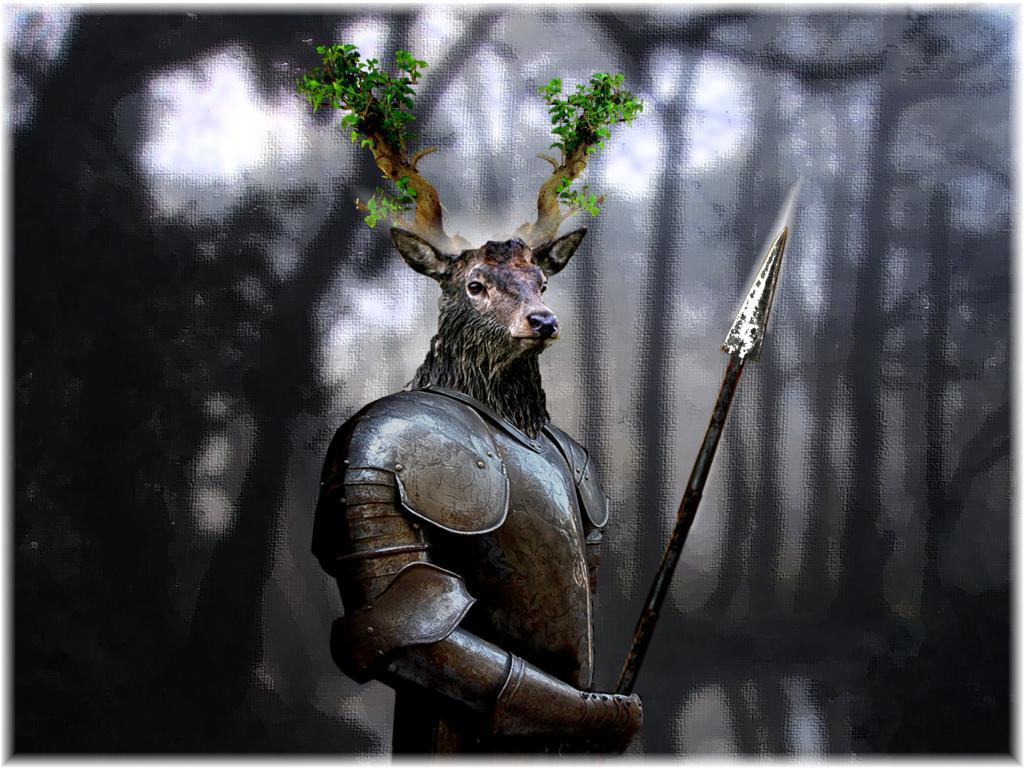What type of statue is present in the image? There is a statue of an animal in the image. What can be seen in the background of the image? The background of the image is blurry. What other elements are present in the image besides the statue? There are trees and some objects in the image. What color is the train in the image? There is no train present in the image. 